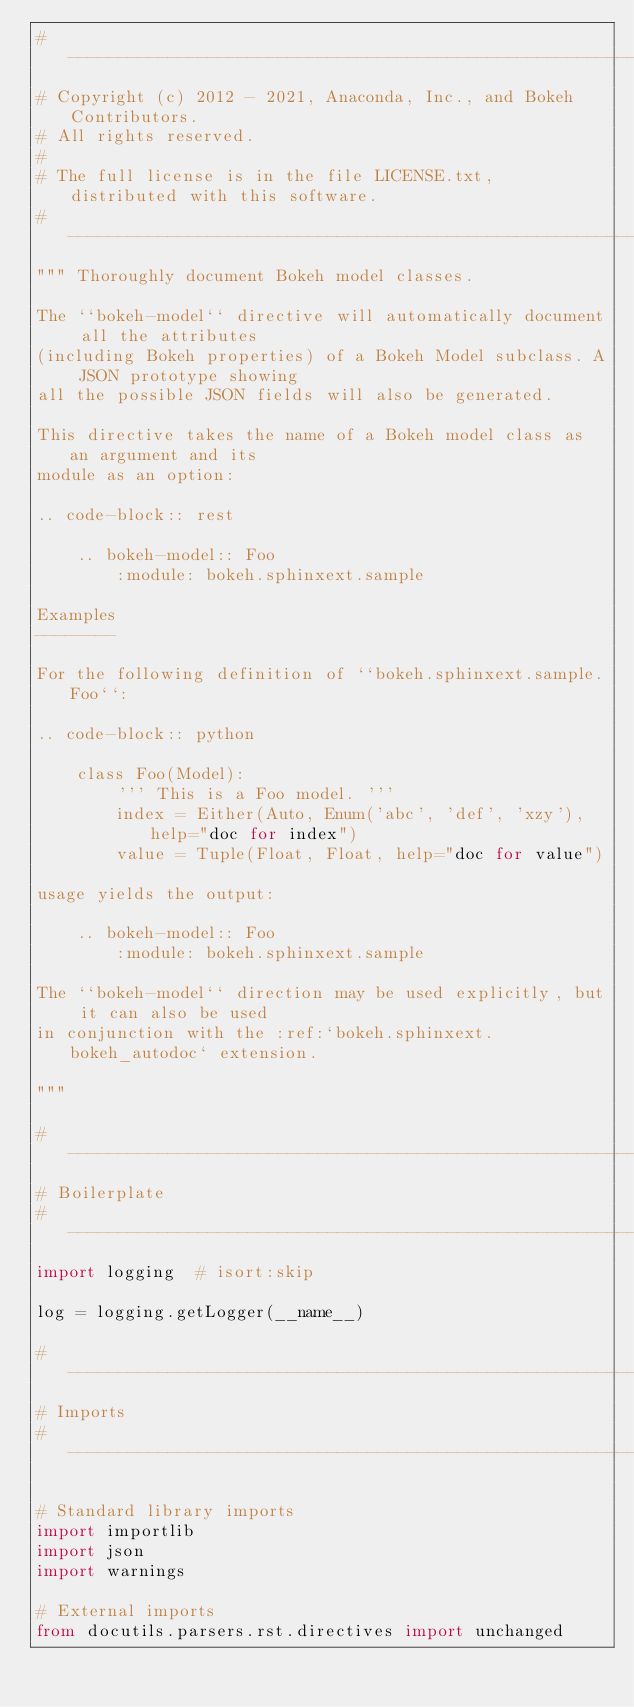<code> <loc_0><loc_0><loc_500><loc_500><_Python_># -----------------------------------------------------------------------------
# Copyright (c) 2012 - 2021, Anaconda, Inc., and Bokeh Contributors.
# All rights reserved.
#
# The full license is in the file LICENSE.txt, distributed with this software.
# -----------------------------------------------------------------------------
""" Thoroughly document Bokeh model classes.

The ``bokeh-model`` directive will automatically document all the attributes
(including Bokeh properties) of a Bokeh Model subclass. A JSON prototype showing
all the possible JSON fields will also be generated.

This directive takes the name of a Bokeh model class as an argument and its
module as an option:

.. code-block:: rest

    .. bokeh-model:: Foo
        :module: bokeh.sphinxext.sample

Examples
--------

For the following definition of ``bokeh.sphinxext.sample.Foo``:

.. code-block:: python

    class Foo(Model):
        ''' This is a Foo model. '''
        index = Either(Auto, Enum('abc', 'def', 'xzy'), help="doc for index")
        value = Tuple(Float, Float, help="doc for value")

usage yields the output:

    .. bokeh-model:: Foo
        :module: bokeh.sphinxext.sample

The ``bokeh-model`` direction may be used explicitly, but it can also be used
in conjunction with the :ref:`bokeh.sphinxext.bokeh_autodoc` extension.

"""

# -----------------------------------------------------------------------------
# Boilerplate
# -----------------------------------------------------------------------------
import logging  # isort:skip

log = logging.getLogger(__name__)

# -----------------------------------------------------------------------------
# Imports
# -----------------------------------------------------------------------------

# Standard library imports
import importlib
import json
import warnings

# External imports
from docutils.parsers.rst.directives import unchanged</code> 